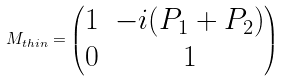Convert formula to latex. <formula><loc_0><loc_0><loc_500><loc_500>M _ { t h i n } = \begin{pmatrix} 1 & - i ( P _ { 1 } + P _ { 2 } ) \\ 0 & 1 \end{pmatrix}</formula> 